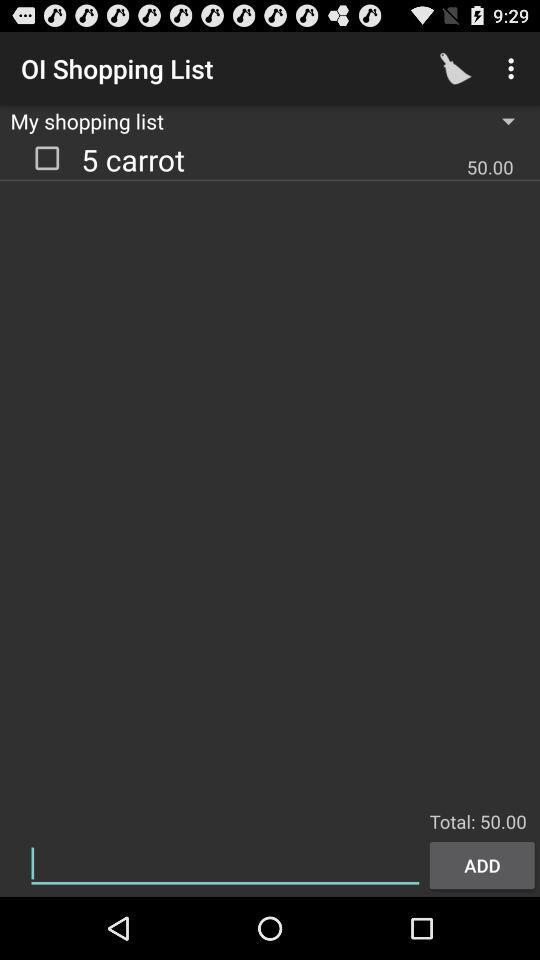What does the shopping list show? The shopping list shows 5 carrots. 